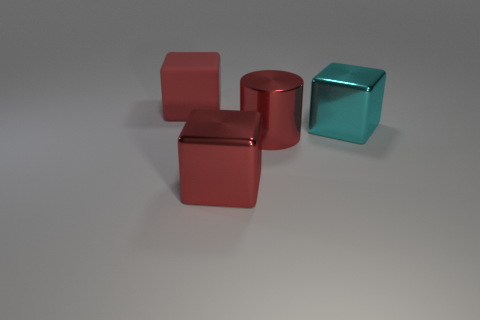Can you infer the size relationship between the objects? From this perspective, the objects look similar in size, but without additional reference points, it's difficult to ascertain scale. They are likely designed to be roughly proportional to each other, offering a harmonic balance in the composition of the image. However, to determine the exact size relationship, we'd need more context or a common object to compare them with. 